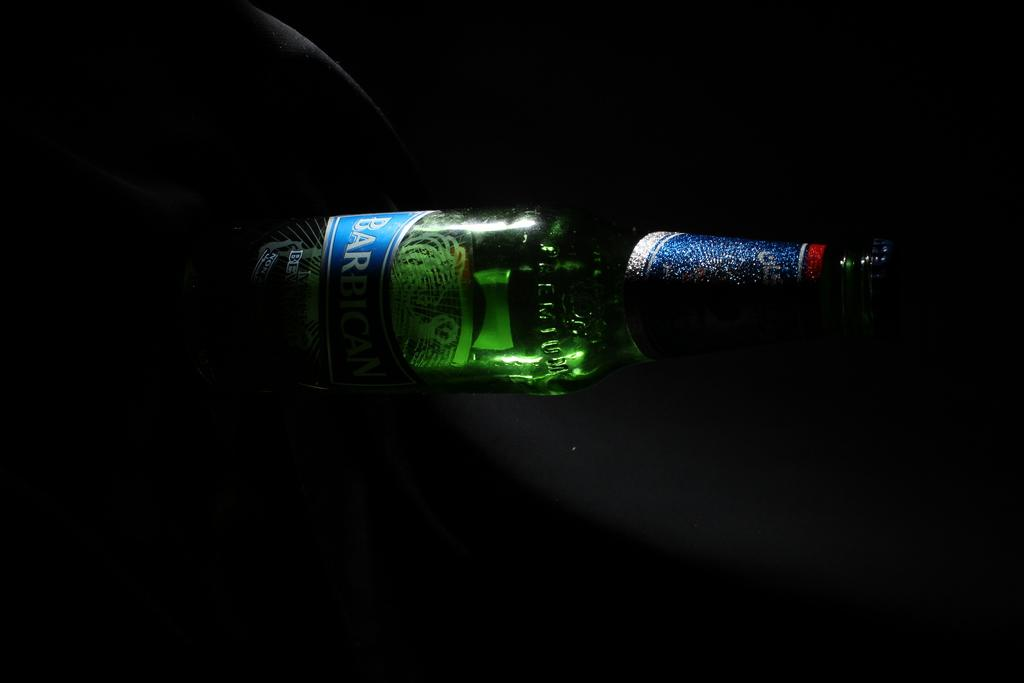<image>
Relay a brief, clear account of the picture shown. Green Barbican beer bottle inside of a dark area. 